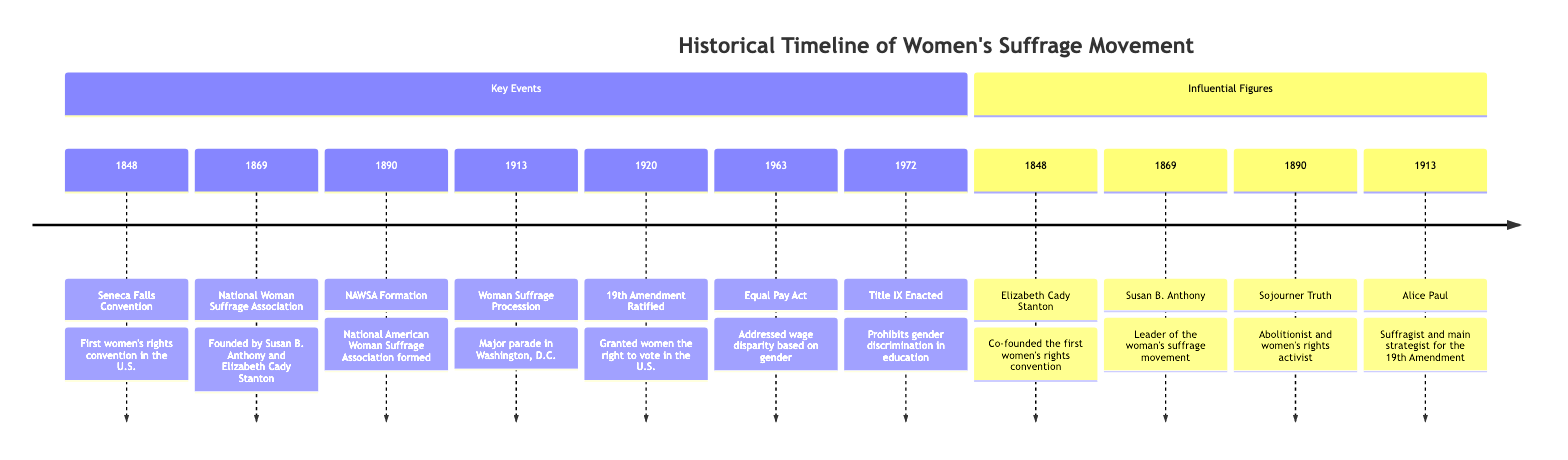What year was the Seneca Falls Convention held? The diagram states that the Seneca Falls Convention took place in 1848, as indicated in the Key Events section.
Answer: 1848 Who were the founders of the National Woman Suffrage Association? According to the diagram, the National Woman Suffrage Association was founded by Susan B. Anthony and Elizabeth Cady Stanton in 1869.
Answer: Susan B. Anthony and Elizabeth Cady Stanton What significant event occurred in 1920? The diagram highlights that in 1920, the 19th Amendment was ratified, granting women the right to vote in the U.S., as listed under Key Events.
Answer: 19th Amendment Ratified How many influential figures are listed in the diagram? The diagram presents four influential figures: Elizabeth Cady Stanton, Susan B. Anthony, Sojourner Truth, and Alice Paul, leading us to conclude there are four figures in total.
Answer: 4 Which act was passed in 1963 to address wage disparity? The diagram describes the Equal Pay Act, enacted in 1963, which addressed wage disparity based on gender.
Answer: Equal Pay Act What was the primary role of Alice Paul according to this diagram? The diagram states that Alice Paul was a suffragist and the main strategist for the 19th Amendment, as specified in the Influential Figures section.
Answer: Main strategist for the 19th Amendment Which event is directly associated with 1913 in the timeline? In the timeline, the Woman Suffrage Procession is noted as the key event, which took place in 1913, highlighted under Key Events.
Answer: Woman Suffrage Procession What is the purpose of Title IX as mentioned in the diagram? According to the diagram, Title IX, enacted in 1972, prohibits gender discrimination in education, which is explicitly stated in the Key Events section.
Answer: Prohibits gender discrimination in education Where is the formation of the National American Woman Suffrage Association noted? The diagram indicates the formation of the National American Woman Suffrage Association (NAWSA) in 1890 under the Key Events section, making it clear where this information can be found.
Answer: 1890 